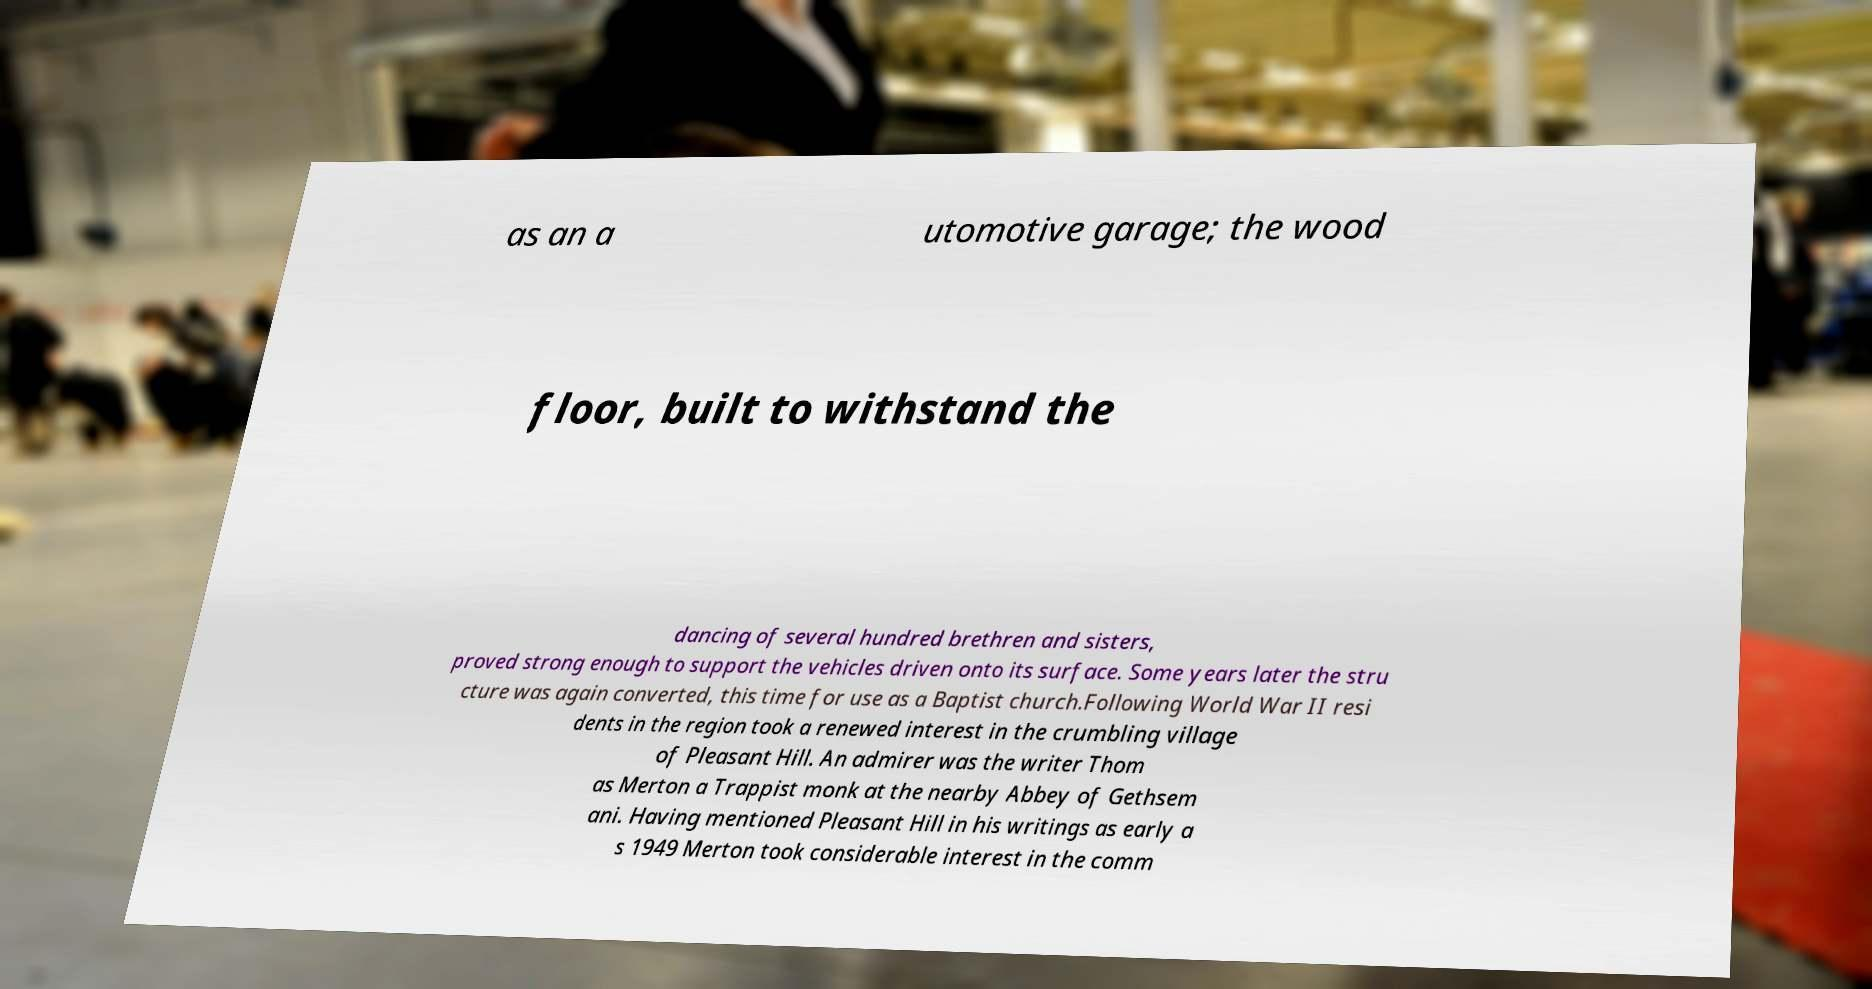What messages or text are displayed in this image? I need them in a readable, typed format. as an a utomotive garage; the wood floor, built to withstand the dancing of several hundred brethren and sisters, proved strong enough to support the vehicles driven onto its surface. Some years later the stru cture was again converted, this time for use as a Baptist church.Following World War II resi dents in the region took a renewed interest in the crumbling village of Pleasant Hill. An admirer was the writer Thom as Merton a Trappist monk at the nearby Abbey of Gethsem ani. Having mentioned Pleasant Hill in his writings as early a s 1949 Merton took considerable interest in the comm 